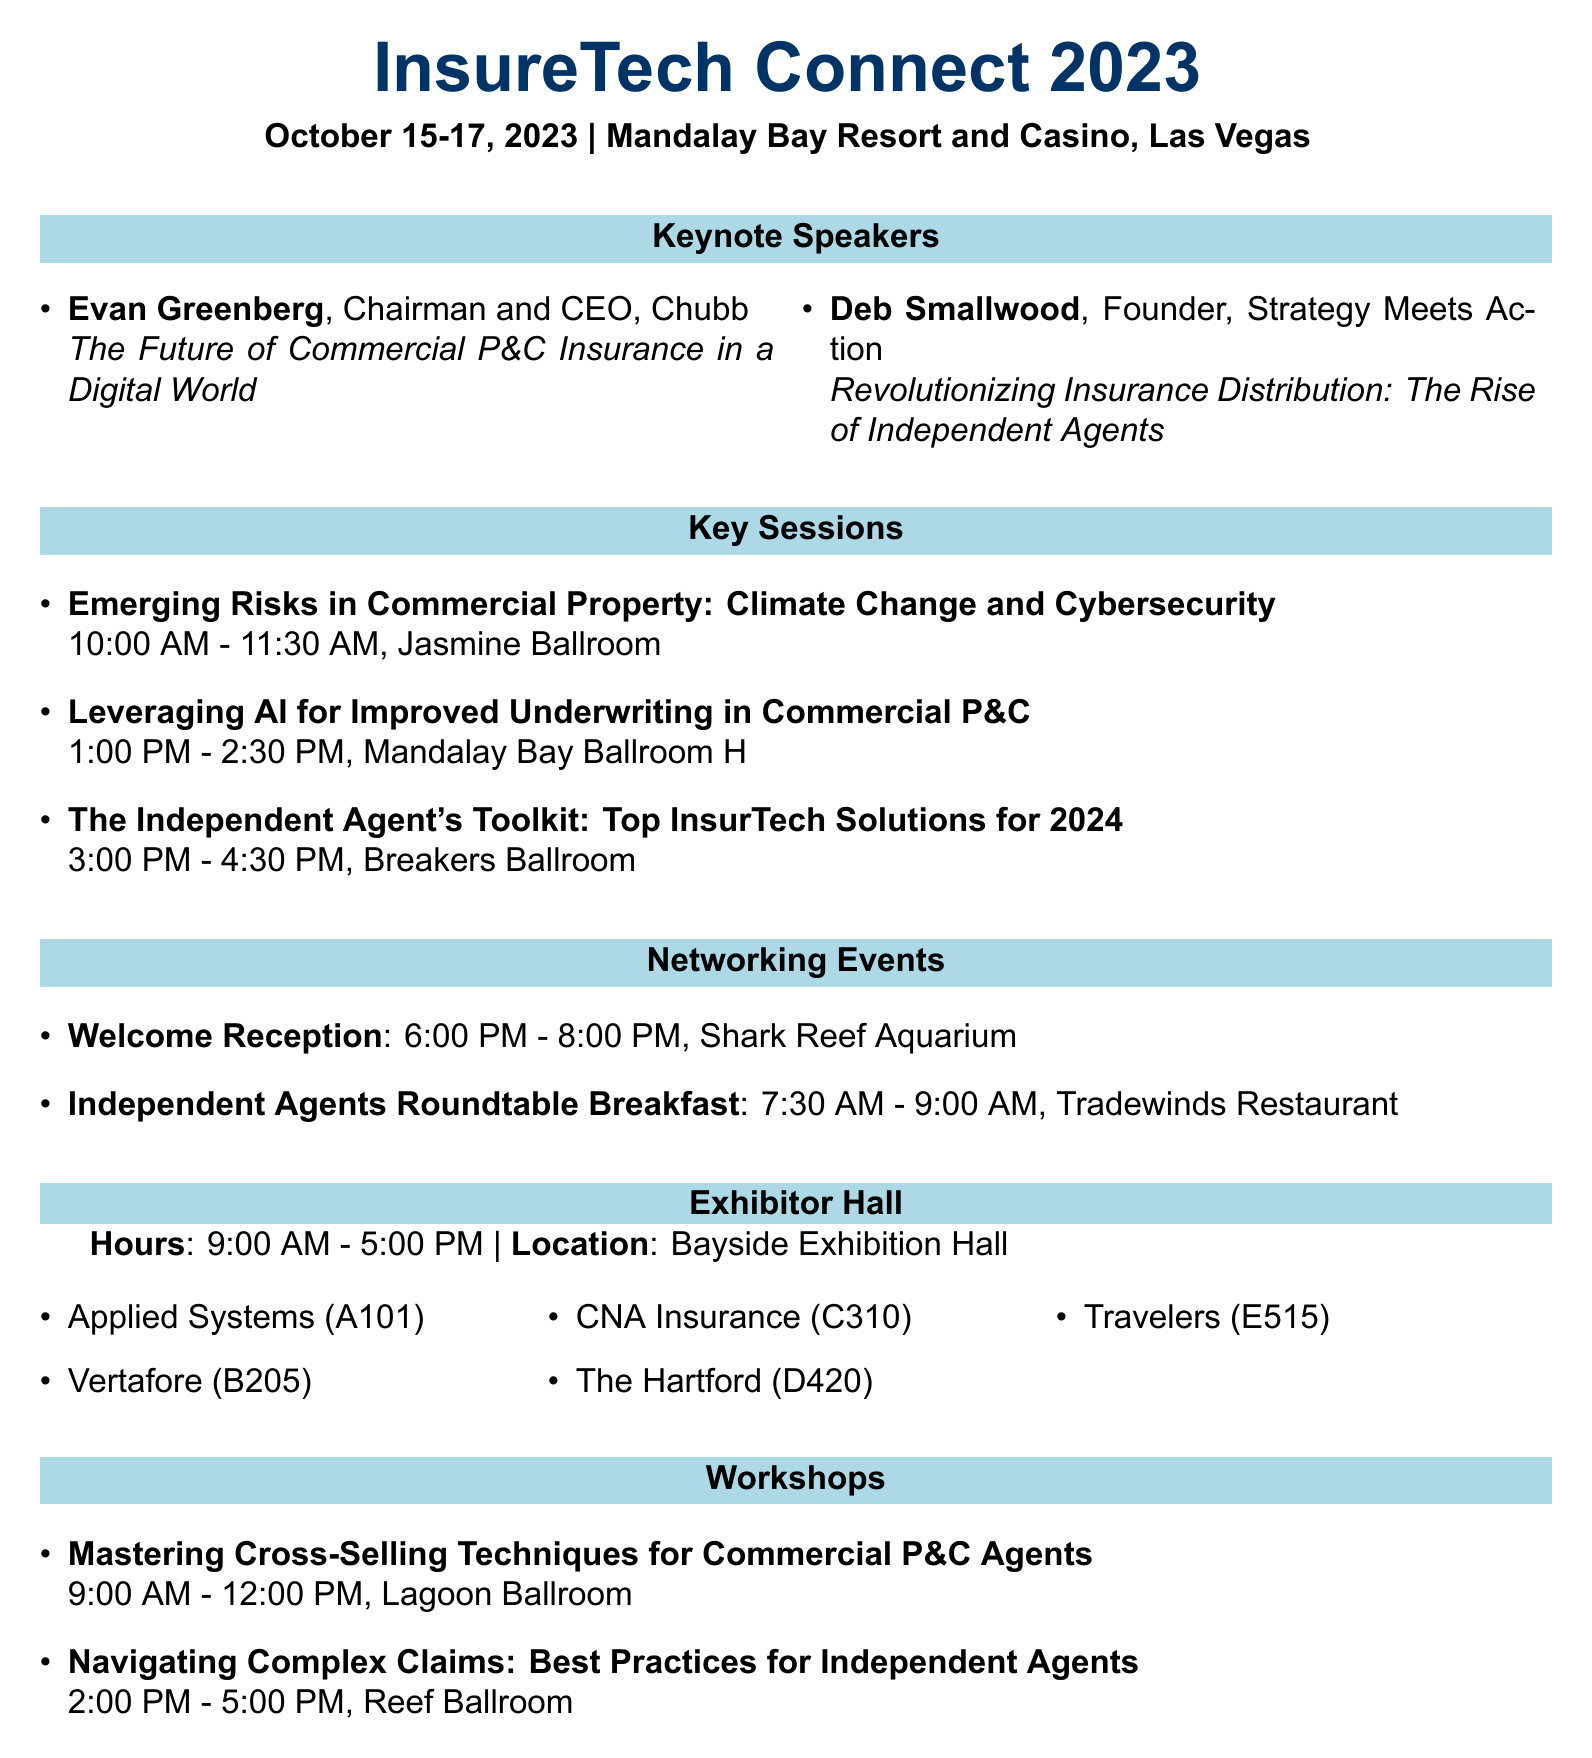What are the dates of the conference? The dates of the conference are explicitly mentioned in the document as October 15-17, 2023.
Answer: October 15-17, 2023 Who is the keynote speaker from Chubb? The document lists Evan Greenberg as the keynote speaker from Chubb.
Answer: Evan Greenberg What is the title of Deb Smallwood's keynote? The title of Deb Smallwood's keynote is provided in the document, showcasing its relevance in the context of independent agents.
Answer: Revolutionizing Insurance Distribution: The Rise of Independent Agents What time does the Welcome Reception start? The start time for the Welcome Reception is specified in the document, giving attendees clear scheduling information.
Answer: 6:00 PM In which ballroom is the workshop on Cross-Selling Techniques held? The document details that the workshop on Cross-Selling Techniques takes place in the Lagoon Ballroom.
Answer: Lagoon Ballroom How many exhibitors are listed in the document? The document outlines the exhibitors, and counting the listed companies reveals the total number.
Answer: 5 What is the name of the event held for independent agents? The document clearly states that there is an event specifically for independent agents, indicating its significance.
Answer: Independent Agents Roundtable Breakfast What is the location of the Exhibitor Hall? The location of the Exhibitor Hall is mentioned in the document, which is important for visitors.
Answer: Bayside Exhibition Hall 